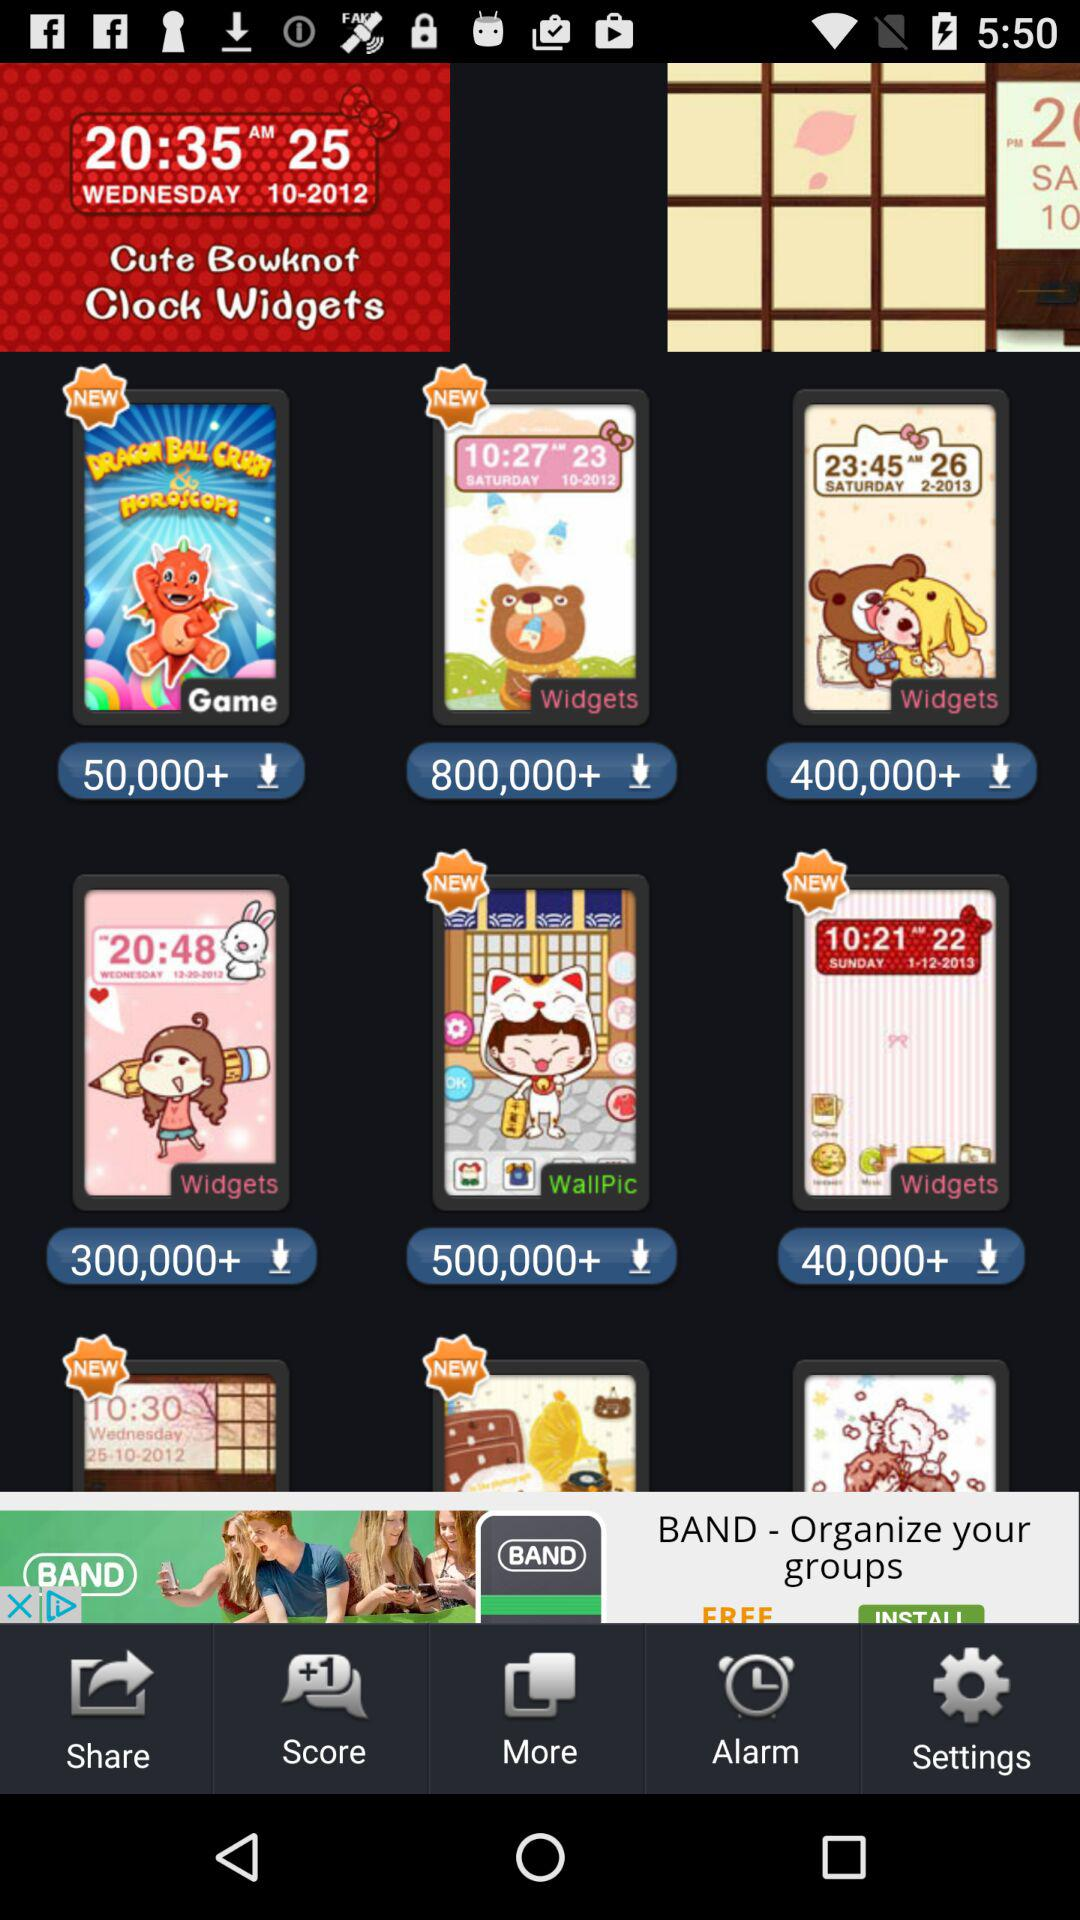What is the given time in the "Cute Bowknot Clock Widgets"? The given time in the "Cute Bowknot Clock Widgets" is 20:35 AM. 